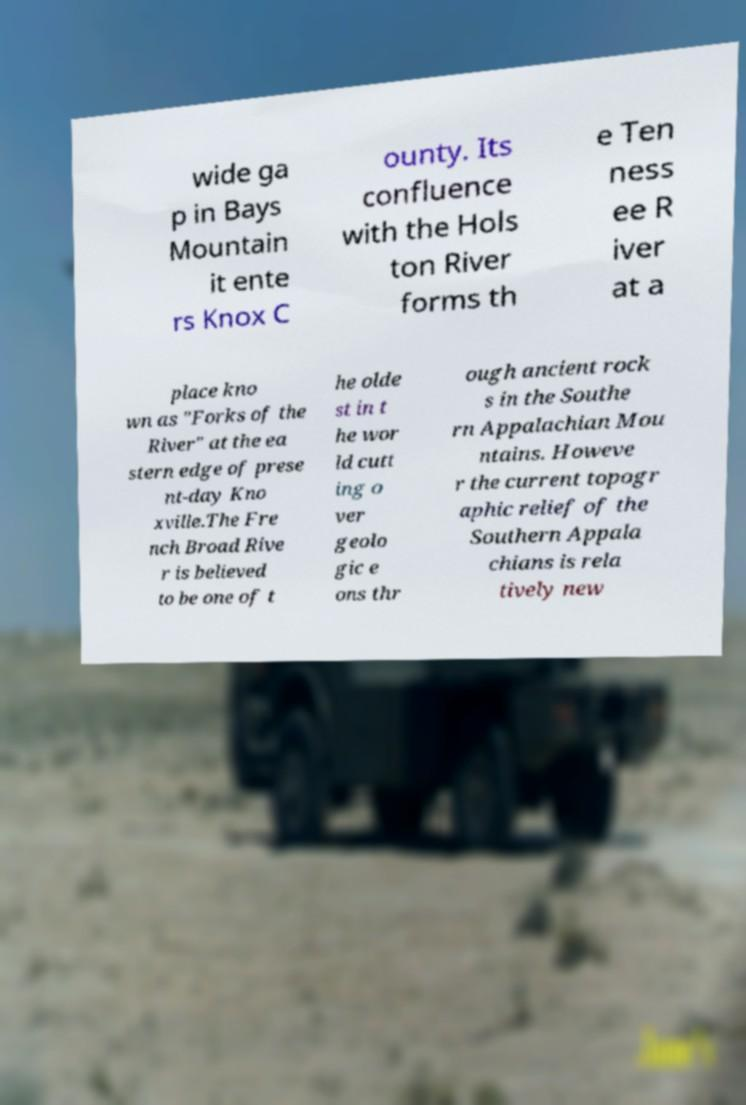Can you accurately transcribe the text from the provided image for me? wide ga p in Bays Mountain it ente rs Knox C ounty. Its confluence with the Hols ton River forms th e Ten ness ee R iver at a place kno wn as "Forks of the River" at the ea stern edge of prese nt-day Kno xville.The Fre nch Broad Rive r is believed to be one of t he olde st in t he wor ld cutt ing o ver geolo gic e ons thr ough ancient rock s in the Southe rn Appalachian Mou ntains. Howeve r the current topogr aphic relief of the Southern Appala chians is rela tively new 